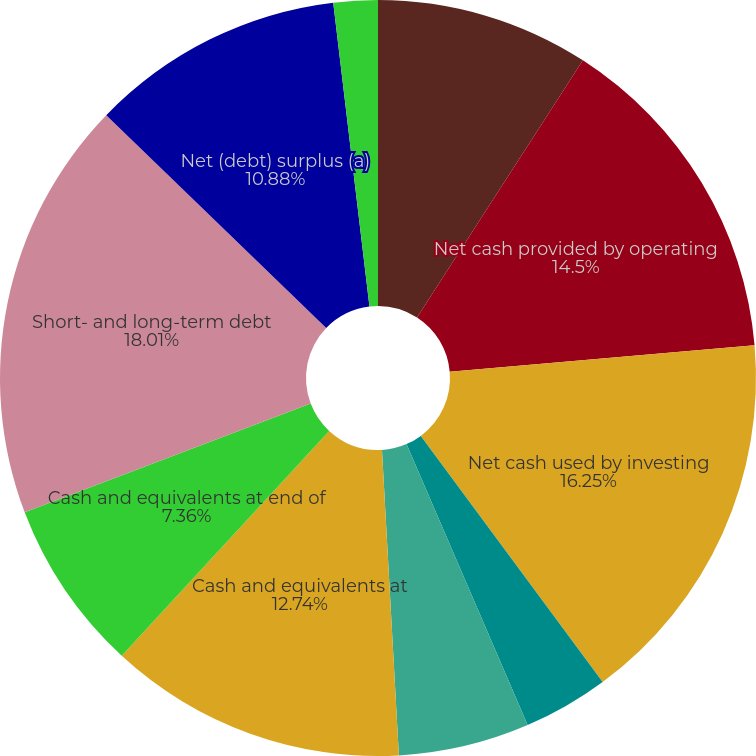Convert chart to OTSL. <chart><loc_0><loc_0><loc_500><loc_500><pie_chart><fcel>Year Ended December 31<fcel>Net cash provided by operating<fcel>Net cash used by investing<fcel>Net cash used by financing<fcel>Net (decrease) increase in<fcel>Cash and equivalents at<fcel>Cash and equivalents at end of<fcel>Short- and long-term debt<fcel>Net (debt) surplus (a)<fcel>Debt-to-equity (b)<nl><fcel>9.12%<fcel>14.5%<fcel>16.26%<fcel>3.65%<fcel>5.6%<fcel>12.74%<fcel>7.36%<fcel>18.02%<fcel>10.88%<fcel>1.89%<nl></chart> 